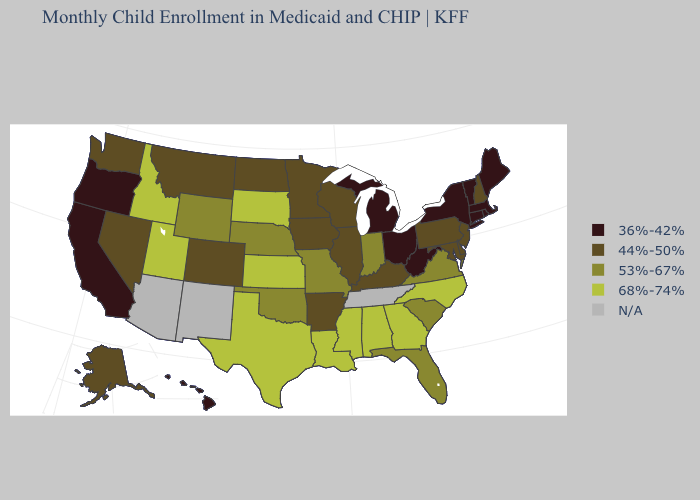Name the states that have a value in the range 36%-42%?
Short answer required. California, Connecticut, Hawaii, Maine, Massachusetts, Michigan, New York, Ohio, Oregon, Rhode Island, Vermont, West Virginia. Does Rhode Island have the highest value in the Northeast?
Short answer required. No. Among the states that border Louisiana , does Mississippi have the highest value?
Concise answer only. Yes. What is the lowest value in the West?
Concise answer only. 36%-42%. What is the highest value in states that border Florida?
Give a very brief answer. 68%-74%. Name the states that have a value in the range 44%-50%?
Short answer required. Alaska, Arkansas, Colorado, Delaware, Illinois, Iowa, Kentucky, Maryland, Minnesota, Montana, Nevada, New Hampshire, New Jersey, North Dakota, Pennsylvania, Washington, Wisconsin. Does the first symbol in the legend represent the smallest category?
Be succinct. Yes. Name the states that have a value in the range 68%-74%?
Give a very brief answer. Alabama, Georgia, Idaho, Kansas, Louisiana, Mississippi, North Carolina, South Dakota, Texas, Utah. What is the highest value in the Northeast ?
Short answer required. 44%-50%. Name the states that have a value in the range 36%-42%?
Write a very short answer. California, Connecticut, Hawaii, Maine, Massachusetts, Michigan, New York, Ohio, Oregon, Rhode Island, Vermont, West Virginia. Does Idaho have the lowest value in the USA?
Concise answer only. No. What is the value of Michigan?
Keep it brief. 36%-42%. Which states have the highest value in the USA?
Answer briefly. Alabama, Georgia, Idaho, Kansas, Louisiana, Mississippi, North Carolina, South Dakota, Texas, Utah. 